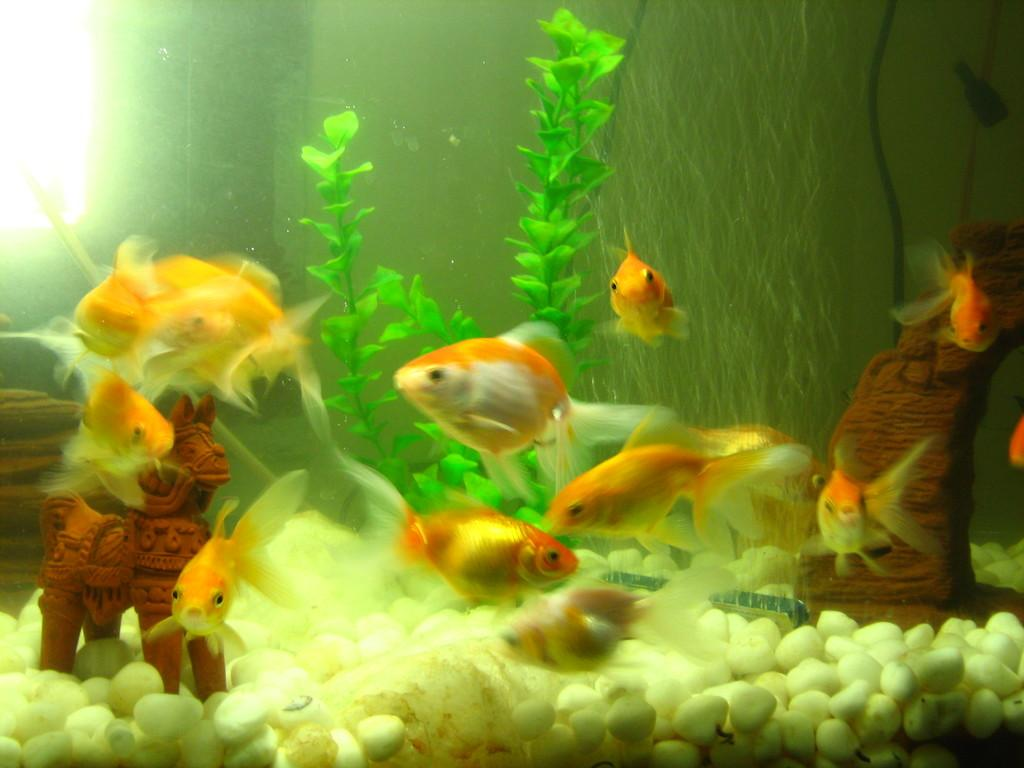What type of animals can be seen in the aquarium in the image? There are fishes in the aquarium in the image. What other objects are present in the aquarium besides the fishes? There is a plant, a toy, and white color stones in the aquarium. Where is the light located in the image? There is a light in the top left corner of the image. What type of alley can be seen in the image? There is no alley present in the image; it features an aquarium with fishes, a plant, a toy, white color stones, and a light. 